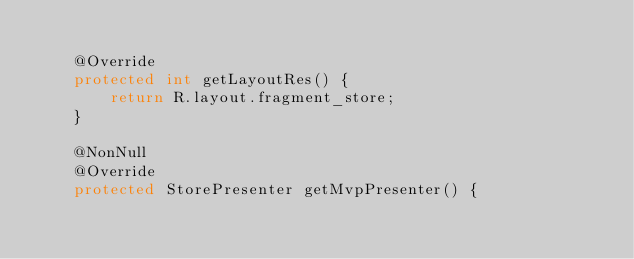Convert code to text. <code><loc_0><loc_0><loc_500><loc_500><_Java_>
    @Override
    protected int getLayoutRes() {
        return R.layout.fragment_store;
    }

    @NonNull
    @Override
    protected StorePresenter getMvpPresenter() {</code> 